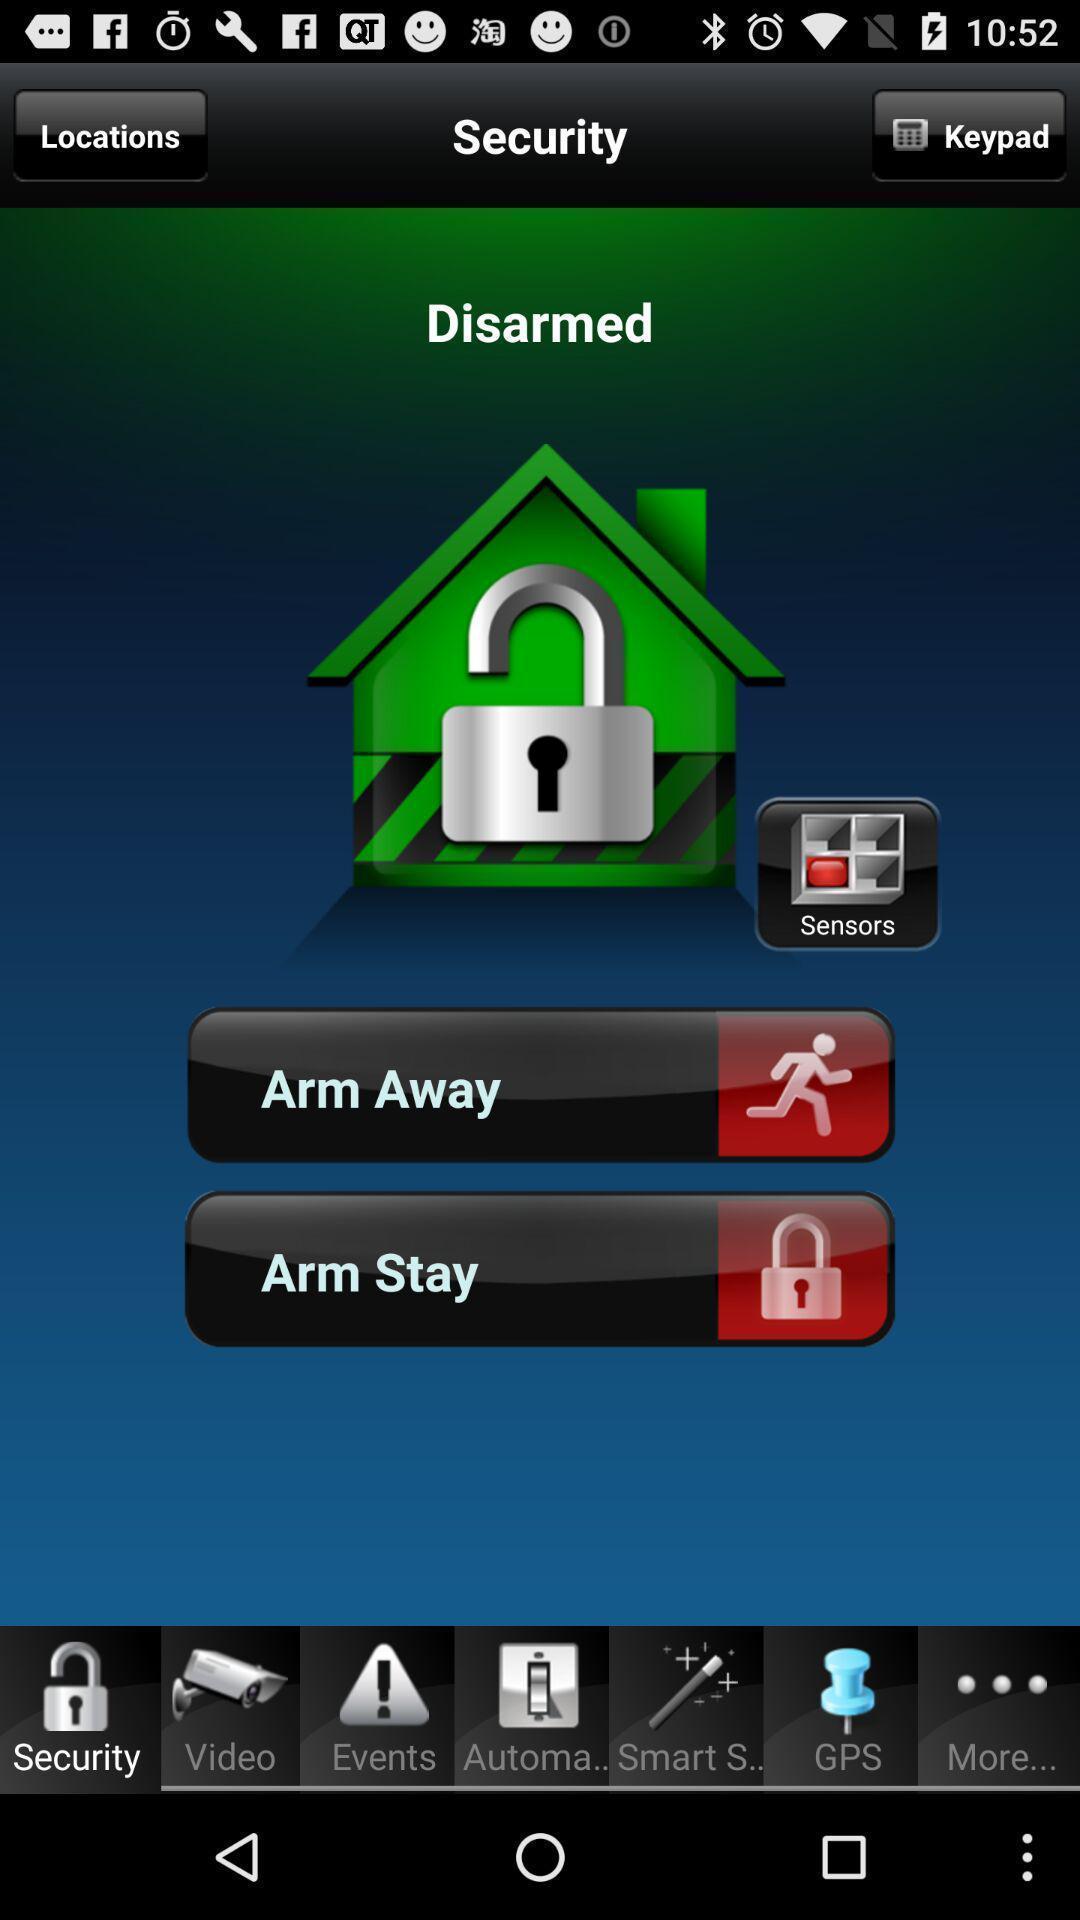What details can you identify in this image? Security options in the application. 